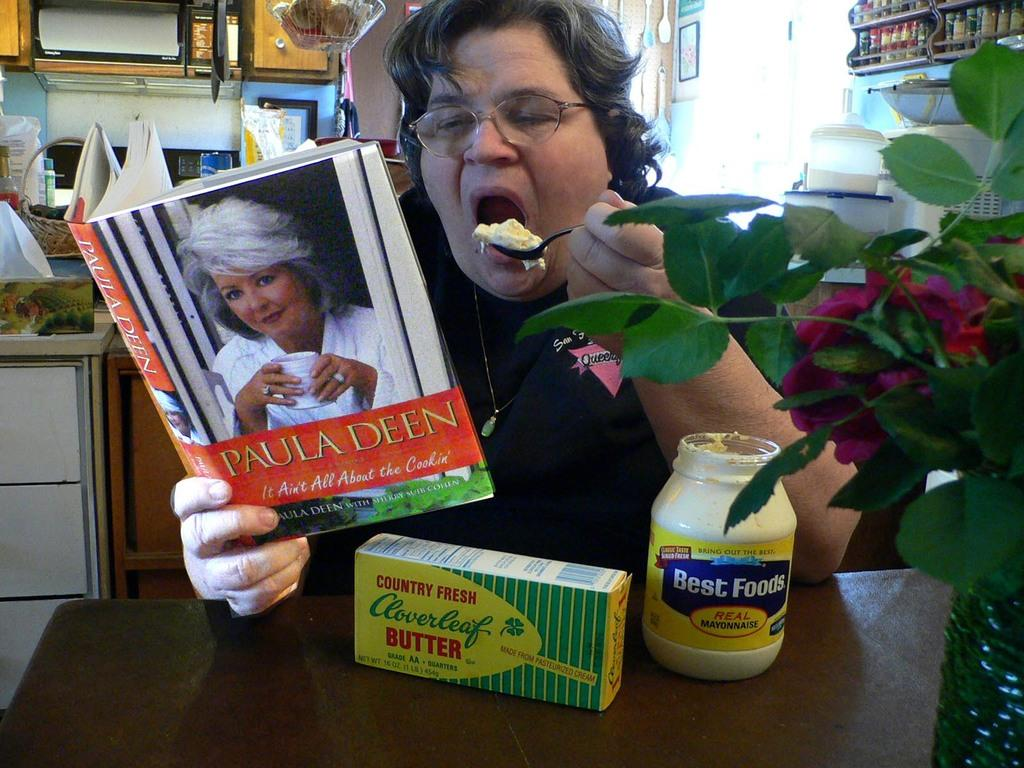<image>
Offer a succinct explanation of the picture presented. A woman is reading a book by Paula Deen and eating Mayonnaise from the jar. 